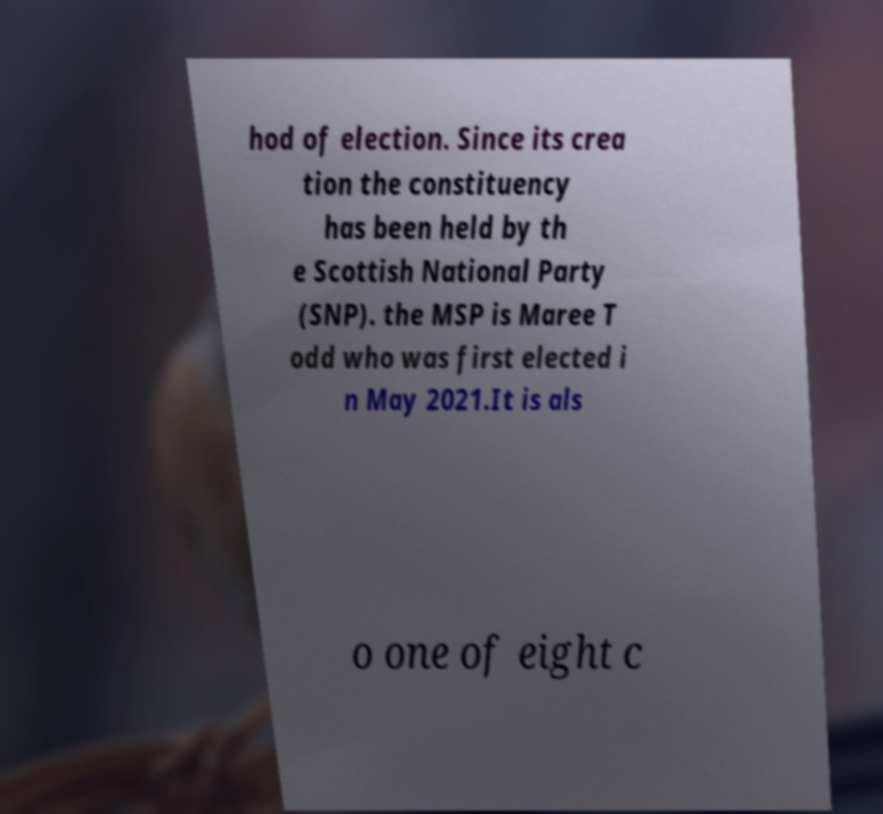Could you assist in decoding the text presented in this image and type it out clearly? hod of election. Since its crea tion the constituency has been held by th e Scottish National Party (SNP). the MSP is Maree T odd who was first elected i n May 2021.It is als o one of eight c 